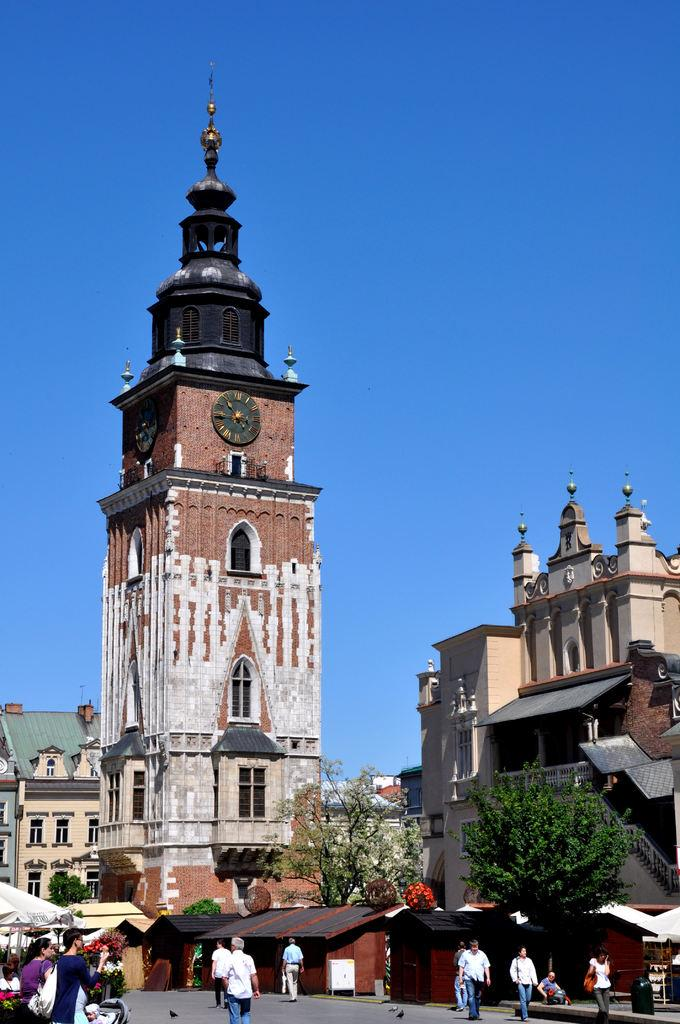What are the people in the image doing? The people in the image are walking in the street. What type of vegetation is present in the image? There are trees in the image. What type of structures can be seen in the image? There are buildings and a tower with a clock in the image. What is the condition of the sky in the image? The sky is clear in the image. How many hats can be seen on the chairs in the image? There are no hats or chairs present in the image. What type of mother is depicted in the image? There is no mother depicted in the image; it features people walking in the street, trees, buildings, and a tower with a clock. 